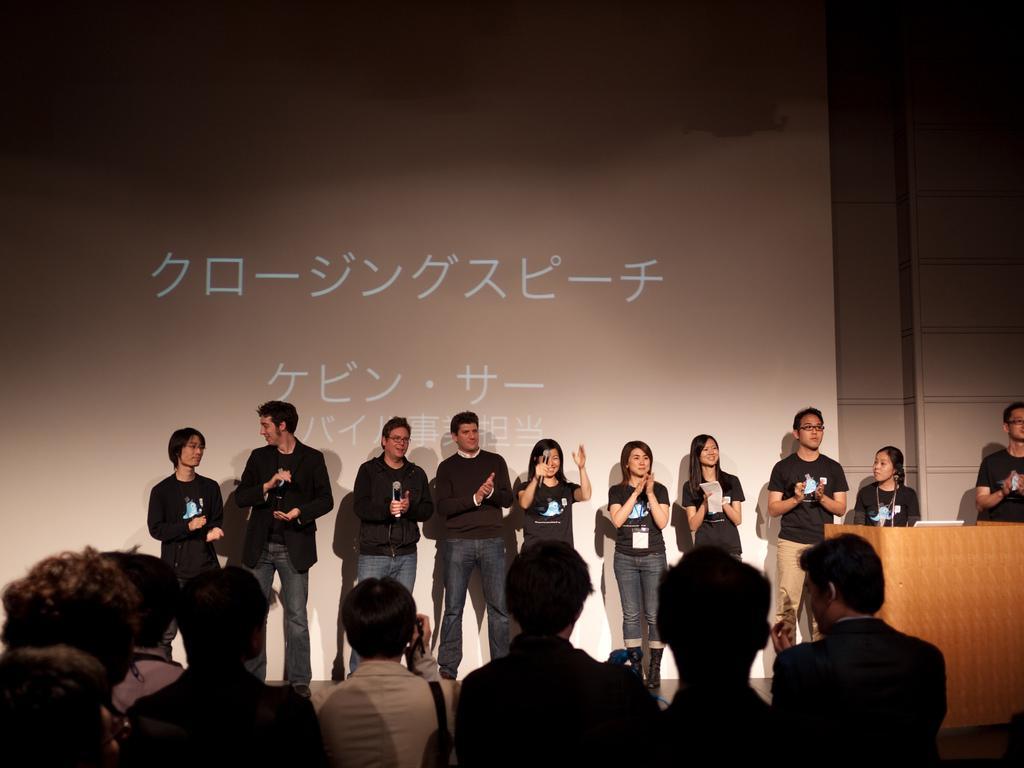Describe this image in one or two sentences. In this picture we can see a group of people standing on the stage and the people holding microphones. In front of the people there are groups of people standing. Behind the people there is a screen and a wall. 